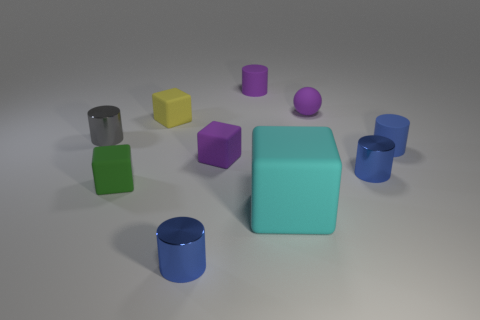Subtract all brown spheres. How many blue cylinders are left? 3 Subtract all yellow cubes. How many cubes are left? 3 Subtract all purple cylinders. How many cylinders are left? 4 Subtract all red cubes. Subtract all purple cylinders. How many cubes are left? 4 Add 1 spheres. How many spheres exist? 2 Subtract 1 blue cylinders. How many objects are left? 9 Subtract all spheres. How many objects are left? 9 Subtract all tiny blue metallic balls. Subtract all purple things. How many objects are left? 7 Add 6 purple rubber objects. How many purple rubber objects are left? 9 